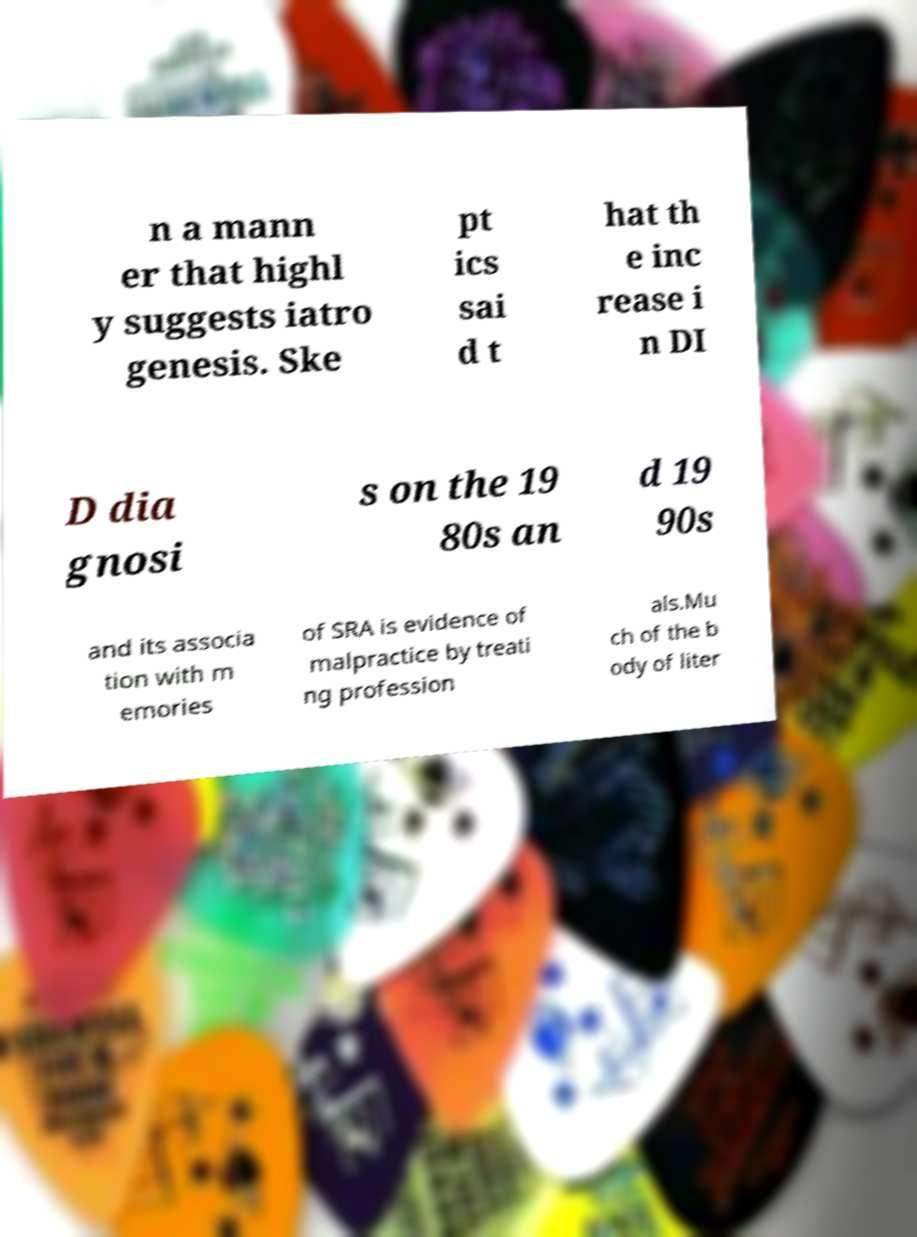Can you accurately transcribe the text from the provided image for me? n a mann er that highl y suggests iatro genesis. Ske pt ics sai d t hat th e inc rease i n DI D dia gnosi s on the 19 80s an d 19 90s and its associa tion with m emories of SRA is evidence of malpractice by treati ng profession als.Mu ch of the b ody of liter 